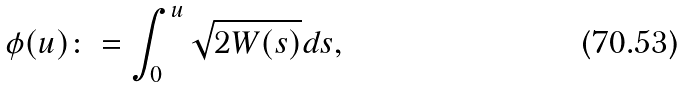<formula> <loc_0><loc_0><loc_500><loc_500>\phi ( u ) \colon = \int _ { 0 } ^ { u } \sqrt { 2 W ( s ) } d s ,</formula> 